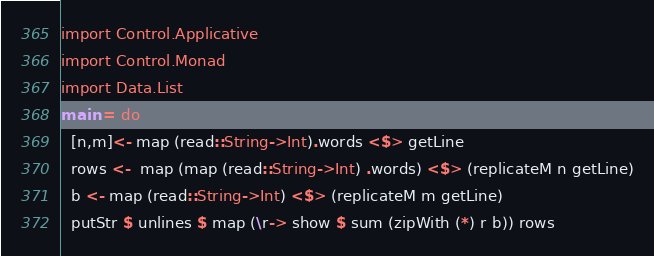Convert code to text. <code><loc_0><loc_0><loc_500><loc_500><_Haskell_>import Control.Applicative
import Control.Monad
import Data.List
main = do
  [n,m]<- map (read::String->Int).words <$> getLine
  rows <-  map (map (read::String->Int) .words) <$> (replicateM n getLine)
  b <- map (read::String->Int) <$> (replicateM m getLine)
  putStr $ unlines $ map (\r-> show $ sum (zipWith (*) r b)) rows</code> 